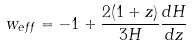<formula> <loc_0><loc_0><loc_500><loc_500>w _ { e f f } = - 1 + \frac { 2 ( 1 + z ) } { 3 H } \frac { d H } { d z }</formula> 